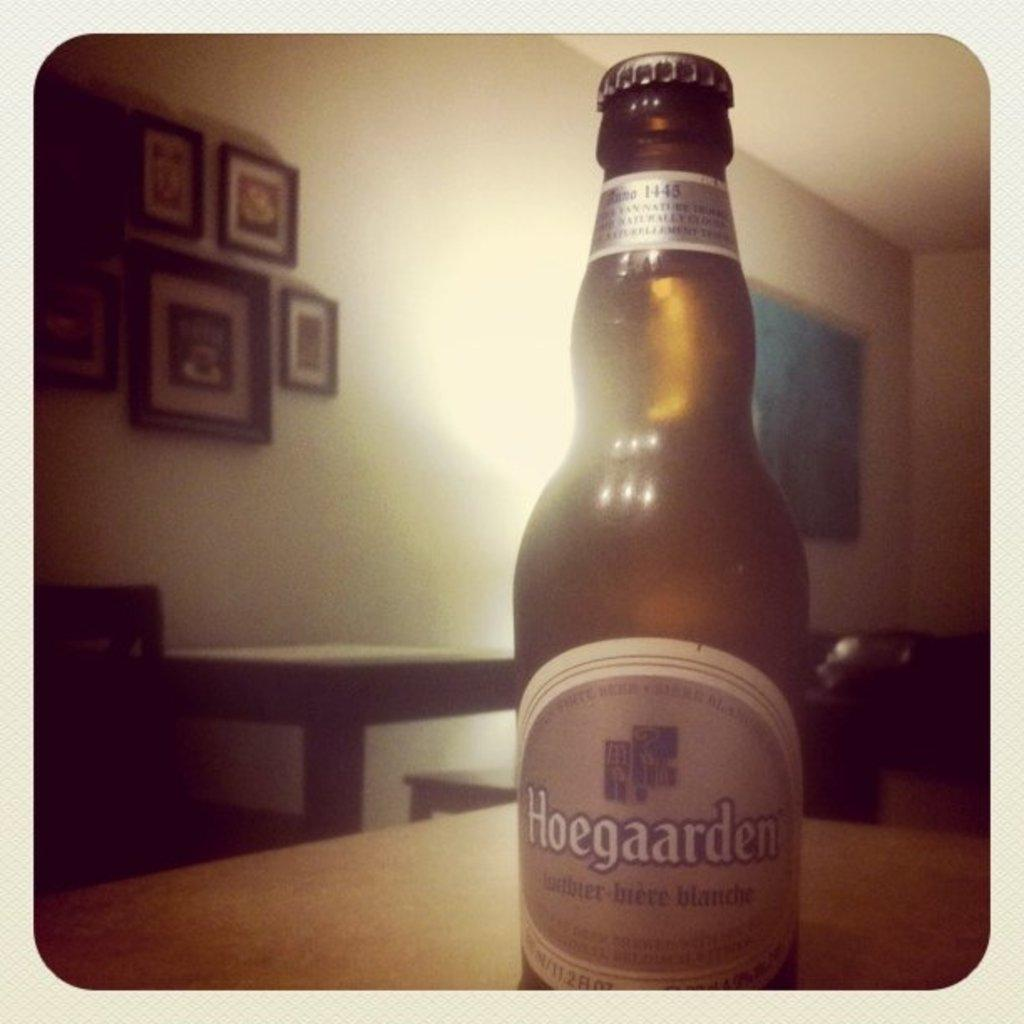Provide a one-sentence caption for the provided image. A bottle of Hoegaarden is sitting on a table with the cap still on. 